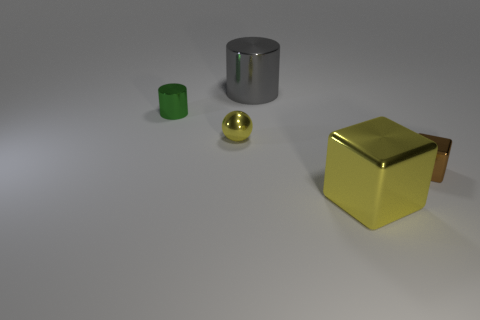Add 3 big green blocks. How many objects exist? 8 Subtract all spheres. How many objects are left? 4 Subtract 0 green cubes. How many objects are left? 5 Subtract all tiny rubber objects. Subtract all big yellow shiny things. How many objects are left? 4 Add 5 big yellow metal things. How many big yellow metal things are left? 6 Add 3 gray cylinders. How many gray cylinders exist? 4 